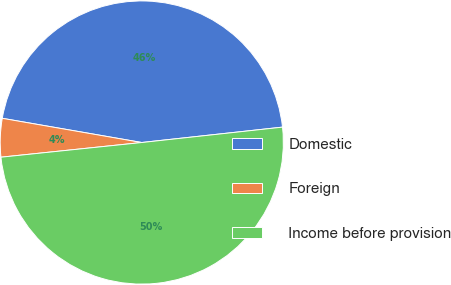Convert chart to OTSL. <chart><loc_0><loc_0><loc_500><loc_500><pie_chart><fcel>Domestic<fcel>Foreign<fcel>Income before provision<nl><fcel>45.53%<fcel>4.39%<fcel>50.08%<nl></chart> 